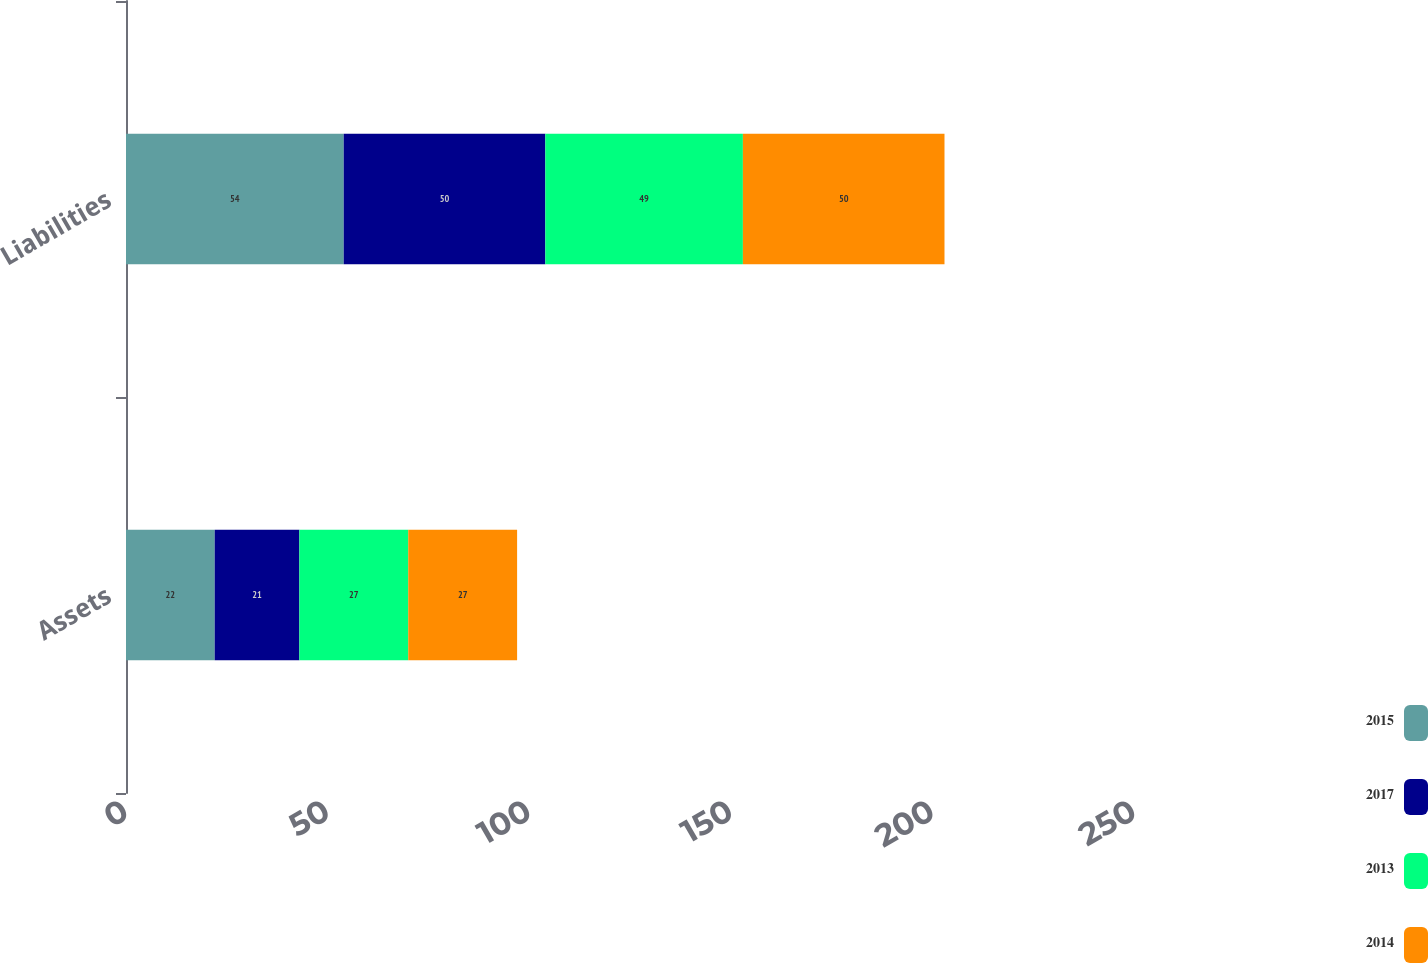Convert chart. <chart><loc_0><loc_0><loc_500><loc_500><stacked_bar_chart><ecel><fcel>Assets<fcel>Liabilities<nl><fcel>2015<fcel>22<fcel>54<nl><fcel>2017<fcel>21<fcel>50<nl><fcel>2013<fcel>27<fcel>49<nl><fcel>2014<fcel>27<fcel>50<nl></chart> 